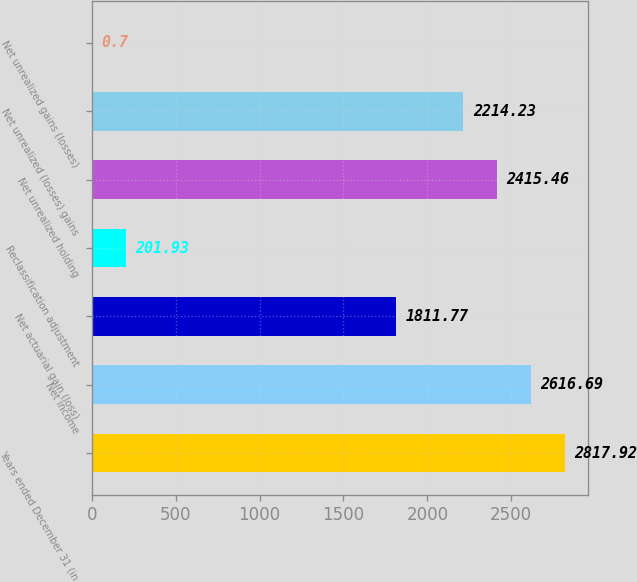Convert chart. <chart><loc_0><loc_0><loc_500><loc_500><bar_chart><fcel>Years ended December 31 (in<fcel>Net income<fcel>Net actuarial gain (loss)<fcel>Reclassification adjustment<fcel>Net unrealized holding<fcel>Net unrealized (losses) gains<fcel>Net unrealized gains (losses)<nl><fcel>2817.92<fcel>2616.69<fcel>1811.77<fcel>201.93<fcel>2415.46<fcel>2214.23<fcel>0.7<nl></chart> 